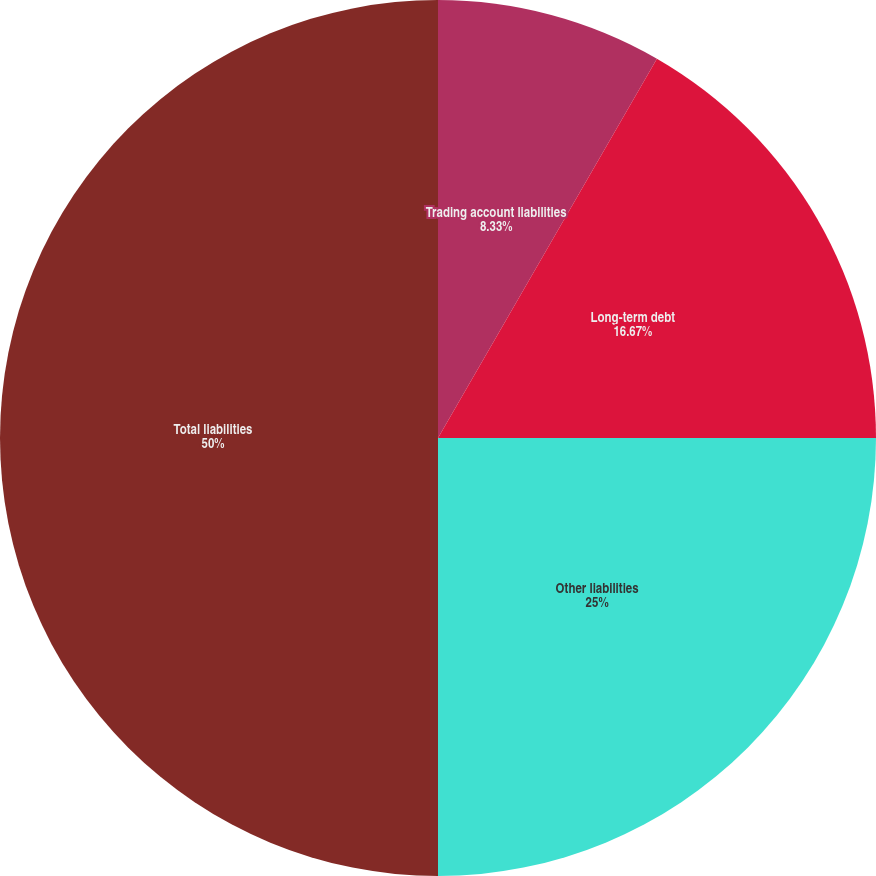<chart> <loc_0><loc_0><loc_500><loc_500><pie_chart><fcel>Trading account liabilities<fcel>Long-term debt<fcel>Other liabilities<fcel>Total liabilities<nl><fcel>8.33%<fcel>16.67%<fcel>25.0%<fcel>50.0%<nl></chart> 